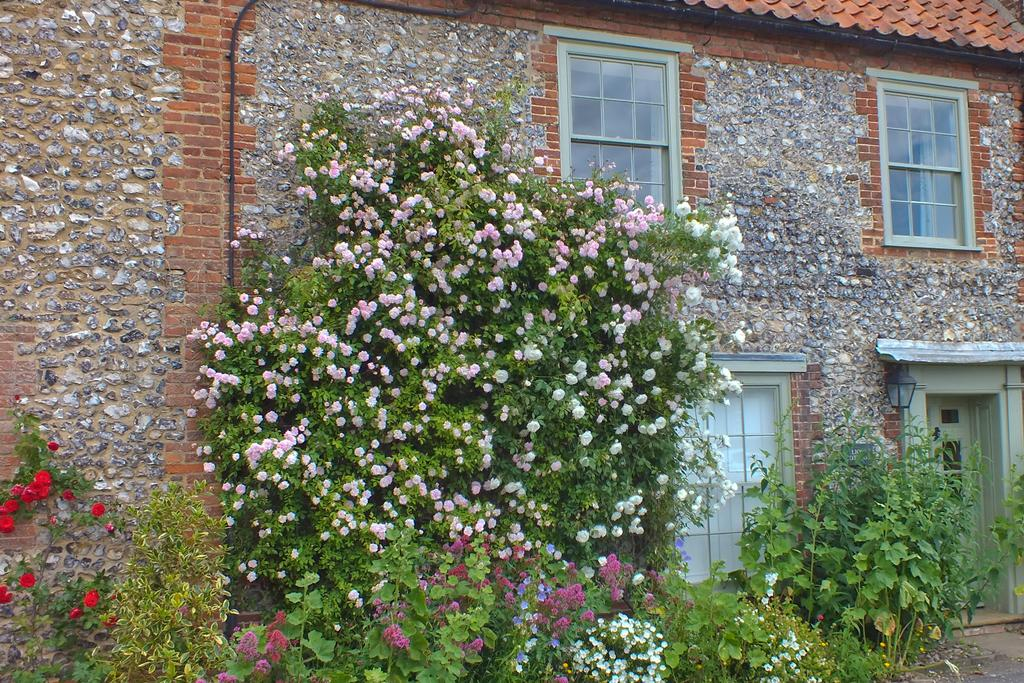What type of natural element can be seen in the image? There is a tree in the image. What other types of vegetation are present in the image? There are plants in the image. What type of structure is visible in the image? There is a house in the image. What features can be seen on the house? The house has windows, and there is a light on the wall of the house. What additional details can be observed about the plants and tree? There are flowers on the plants and tree. What type of insurance policy is mentioned in the image? There is no mention of any insurance policy in the image. How does the wind affect the plants and tree in the image? There is no wind present in the image, so its effect on the plants and tree cannot be determined. 